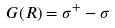Convert formula to latex. <formula><loc_0><loc_0><loc_500><loc_500>G ( R ) = \sigma ^ { + } - \sigma</formula> 